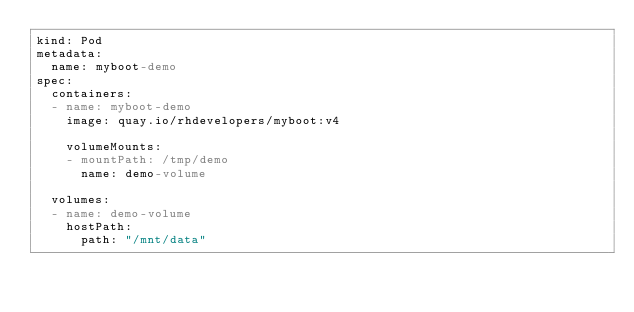<code> <loc_0><loc_0><loc_500><loc_500><_YAML_>kind: Pod
metadata:
  name: myboot-demo
spec:
  containers:
  - name: myboot-demo
    image: quay.io/rhdevelopers/myboot:v4
    
    volumeMounts:
    - mountPath: /tmp/demo
      name: demo-volume

  volumes:
  - name: demo-volume
    hostPath:
      path: "/mnt/data"
</code> 